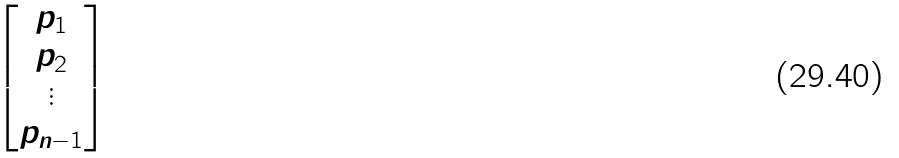<formula> <loc_0><loc_0><loc_500><loc_500>\begin{bmatrix} p _ { 1 } \\ p _ { 2 } \\ \vdots \\ p _ { n - 1 } \end{bmatrix}</formula> 